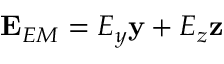Convert formula to latex. <formula><loc_0><loc_0><loc_500><loc_500>E _ { E M } = E _ { y } y + E _ { z } z</formula> 